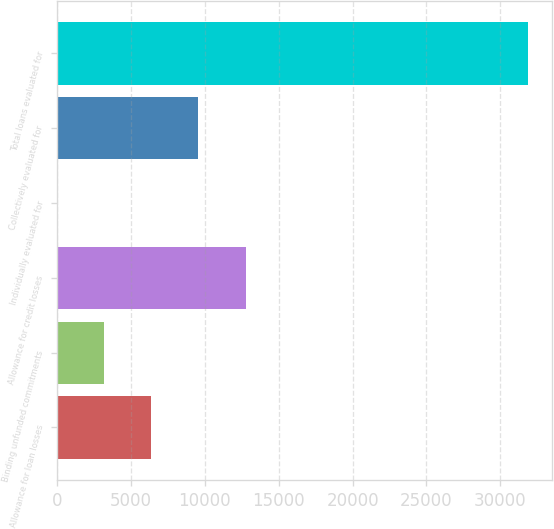Convert chart to OTSL. <chart><loc_0><loc_0><loc_500><loc_500><bar_chart><fcel>Allowance for loan losses<fcel>Binding unfunded commitments<fcel>Allowance for credit losses<fcel>Individually evaluated for<fcel>Collectively evaluated for<fcel>Total loans evaluated for<nl><fcel>6381.6<fcel>3191.8<fcel>12761.2<fcel>2<fcel>9571.4<fcel>31900<nl></chart> 